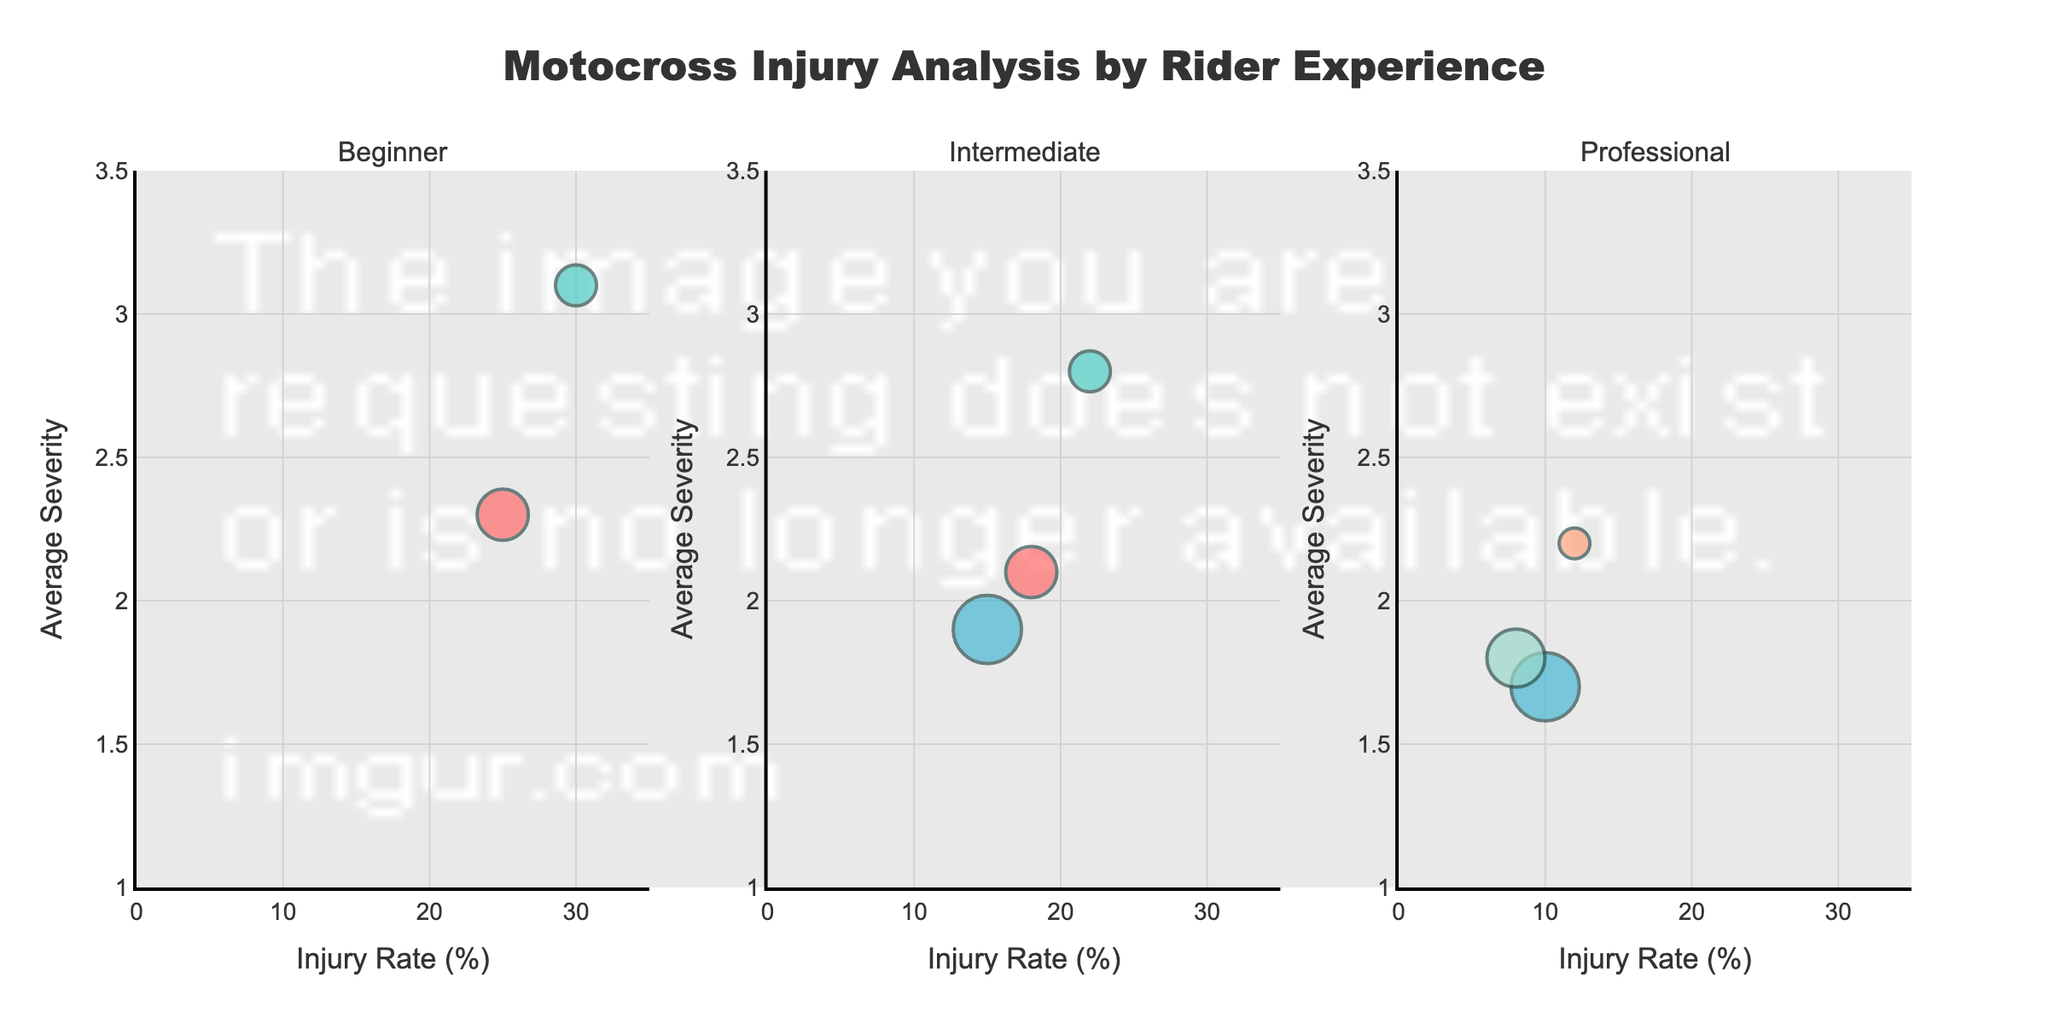What is the title of the chart? The title is located at the top center of the chart and sets the context for the data being visualized.
Answer: Motocross Injury Analysis by Rider Experience How many events are represented in the Beginner subplot? Look at the Beginner subplot and count the number of bubbles, each representing a different event type.
Answer: 2 Which event type has the highest injury rate for Intermediate riders? Check the Intermediate subplot, find the bubble farthest to the right (highest x-axis value) and note its corresponding event type.
Answer: Mud Bog Racing What is the average severity of injuries for Amateur Night Track Race among Intermediate riders? In the Intermediate subplot, find the y-axis value for the corresponding bubble labeled Amateur Night Track Race.
Answer: 2.1 Compare the injury rates of Beginner in Amateur Night Track Race and Professional in Enduro Racing. Which one is higher? Look at the x-axis positions of the corresponding bubbles in their respective subplots and compare their values.
Answer: Beginner in Amateur Night Track Race Within which experience level is the bubble size largest, indicating the highest number of events, and which event type is it? Determine the largest bubble in each subplot, and then compare across all subplots to identify the largest overall. The event type is labeled within the bubble.
Answer: Intermediate, Supercross Which subplot contains the event type with the lowest average severity? Identify the bubble with the lowest y-axis position in each subplot and find which subplot has the smallest y-axis value overall.
Answer: Intermediate What is the difference in injury rate between Professional in Supercross and Professional in Freestyle Motocross? Find the x-axis values for these events within the Professional subplot and calculate the difference.
Answer: 2 Which experience level has the event type with the lowest injury rate overall? Find the event type with the lowest x-axis value in each subplot and compare these to determine the lowest overall.
Answer: Professional What is the total number of events represented in the Professional subplot? Sum the number of events indicated by the number of bubbles in the Professional subplot.
Answer: 3 